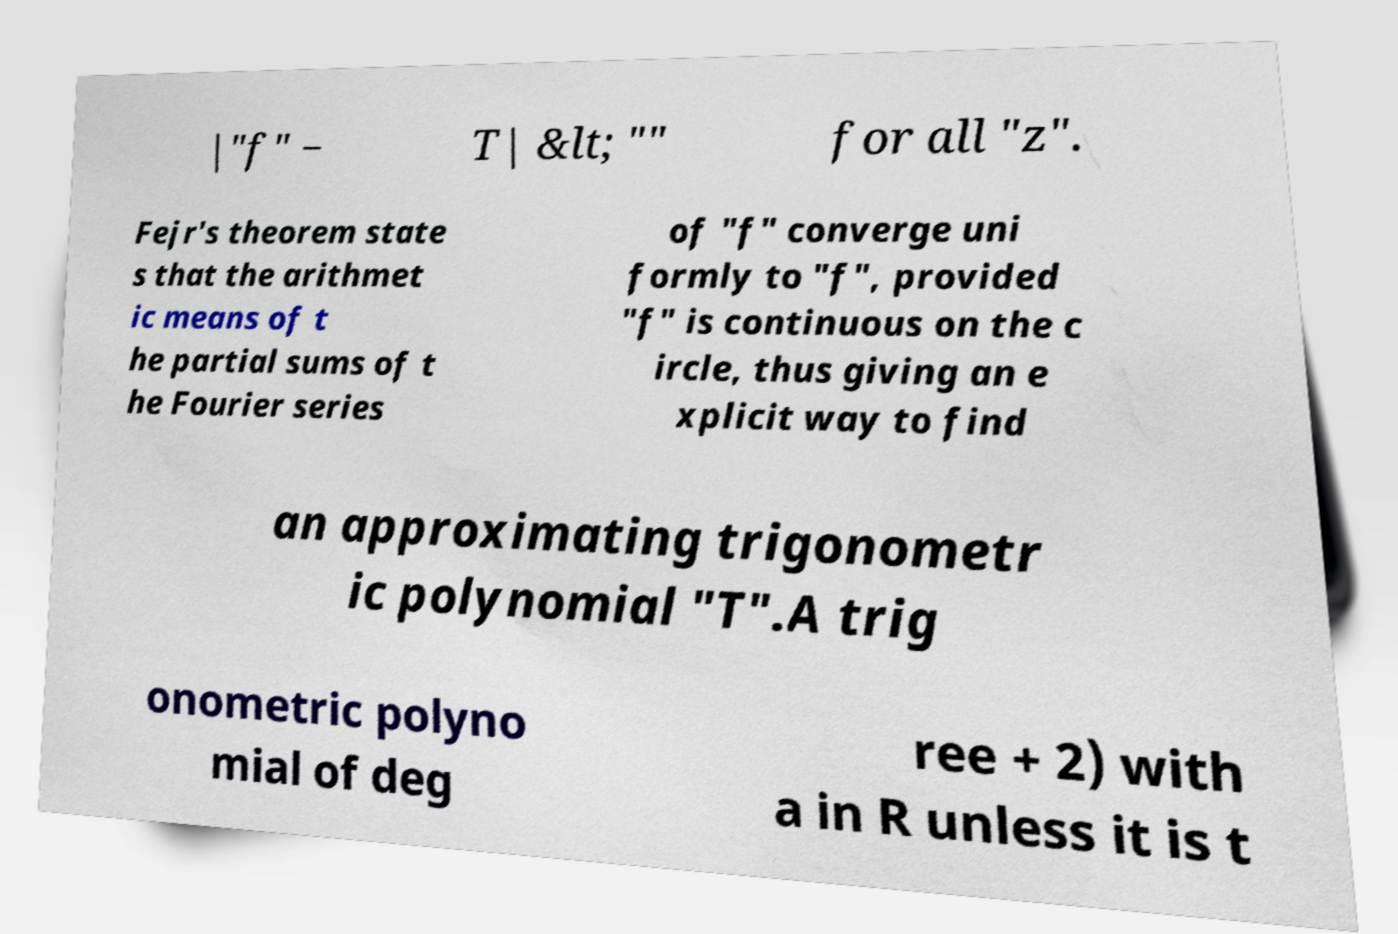Could you extract and type out the text from this image? |"f" − T| &lt; "" for all "z". Fejr's theorem state s that the arithmet ic means of t he partial sums of t he Fourier series of "f" converge uni formly to "f", provided "f" is continuous on the c ircle, thus giving an e xplicit way to find an approximating trigonometr ic polynomial "T".A trig onometric polyno mial of deg ree + 2) with a in R unless it is t 